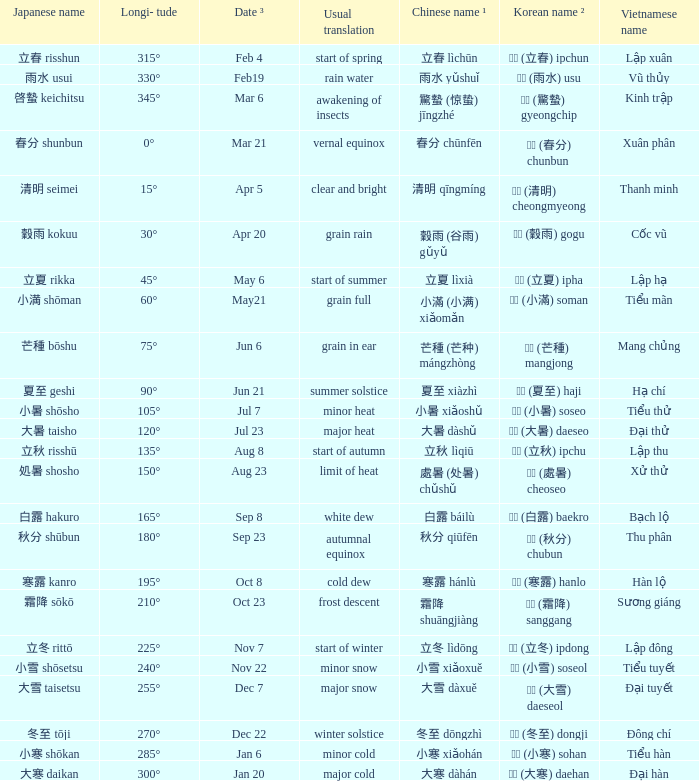WHICH Usual translation is on jun 21? Summer solstice. 